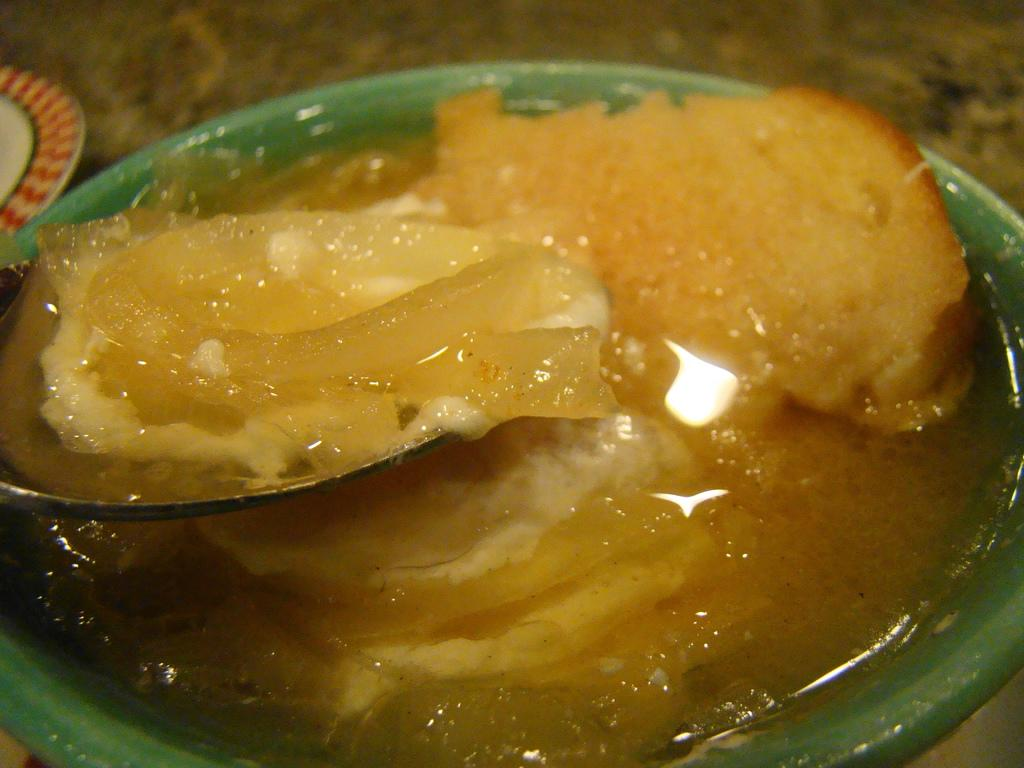What is in the bowl that is visible in the image? There is a bowl with sweet in the image. What utensil is used to eat the sweet in the image? There is a spoon in the bowl. What other dishware can be seen in the image? There is a plate in the background of the image. How much coal is visible in the image? There is no coal present in the image. What type of money is being used to purchase the sweet in the image? There is no money or transaction depicted in the image. 